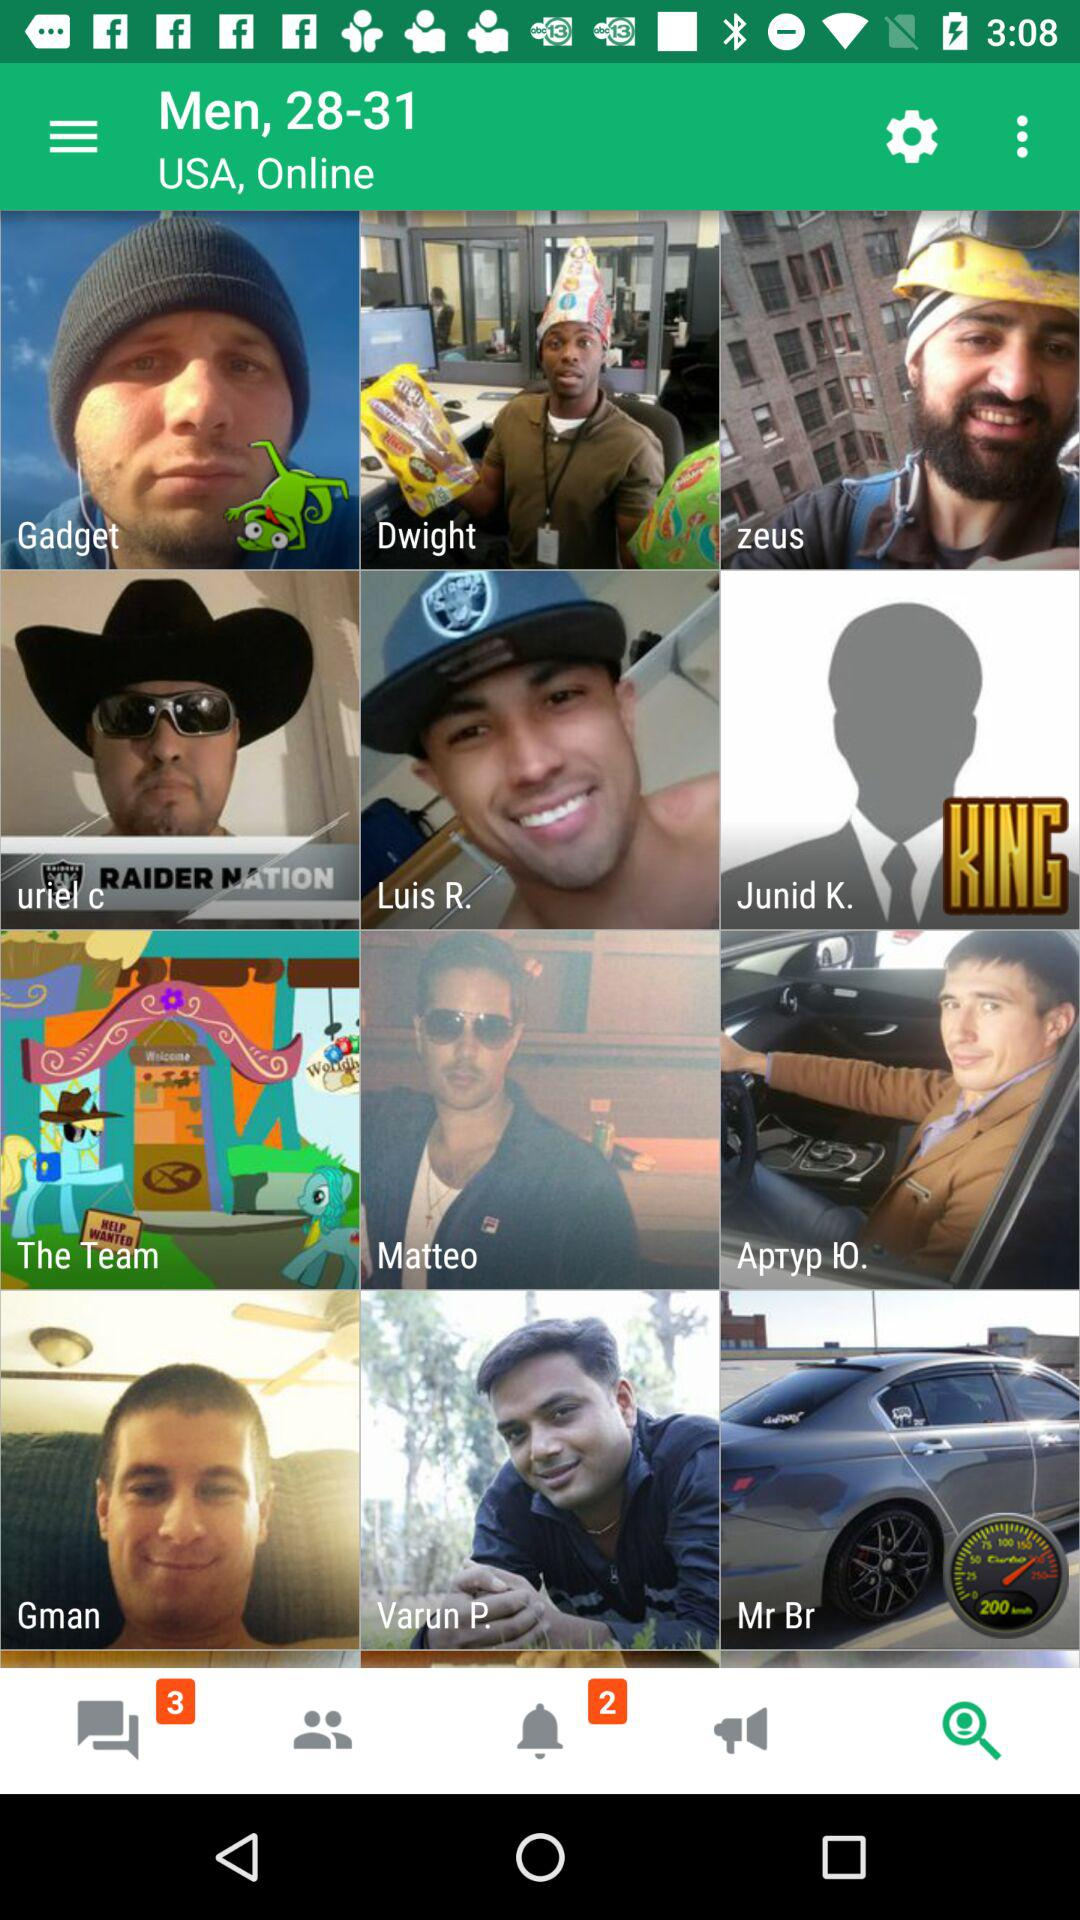Are there any unread notification?
When the provided information is insufficient, respond with <no answer>. <no answer> 